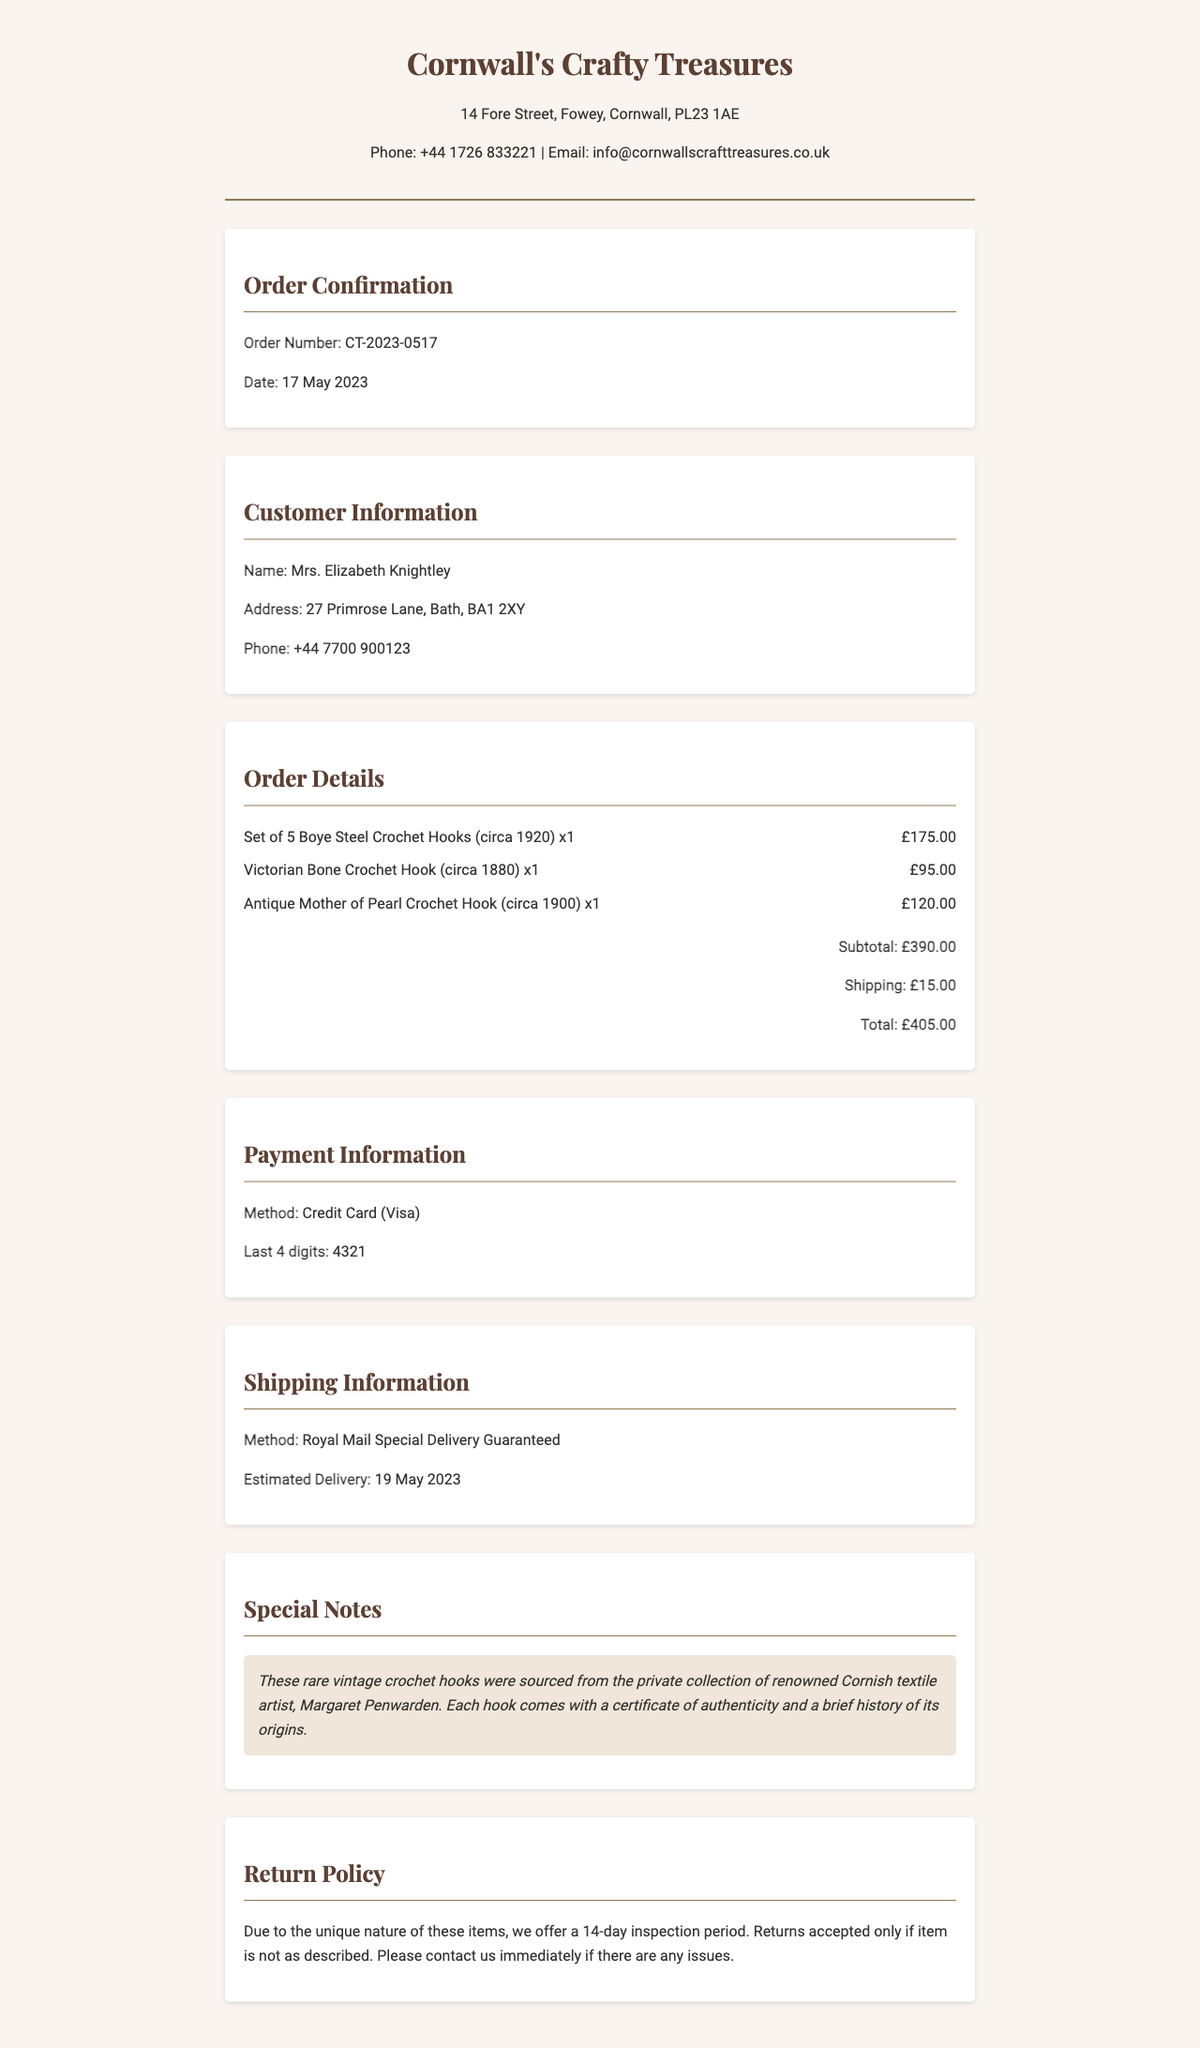What is the order number? The order number is listed in the document format as CT-2023-0517.
Answer: CT-2023-0517 What is the subtotal amount? The subtotal amount is calculated based on the individual items listed in the order details.
Answer: £390.00 Who is the customer? The customer's name is provided in the document under Customer Information.
Answer: Mrs. Elizabeth Knightley When is the estimated delivery date? The estimated delivery date is mentioned in the Shipping Information section.
Answer: 19 May 2023 What is the total amount including shipping? The total amount includes both the subtotal and shipping costs.
Answer: £405.00 What crochet hooks are included in the order? The order details list the specific crochet hooks included in the purchase.
Answer: 5 Boye Steel Crochet Hooks, Victorian Bone Crochet Hook, Antique Mother of Pearl Crochet Hook What is the return policy duration? The return policy duration is specified at the end of the document in the Return Policy section.
Answer: 14-day Who was the source of the crochet hooks? The document mentions the original source of the crochet hooks in the Special Notes section.
Answer: Margaret Penwarden What payment method was used? The payment method is detailed in the Payment Information section of the document.
Answer: Credit Card (Visa) 